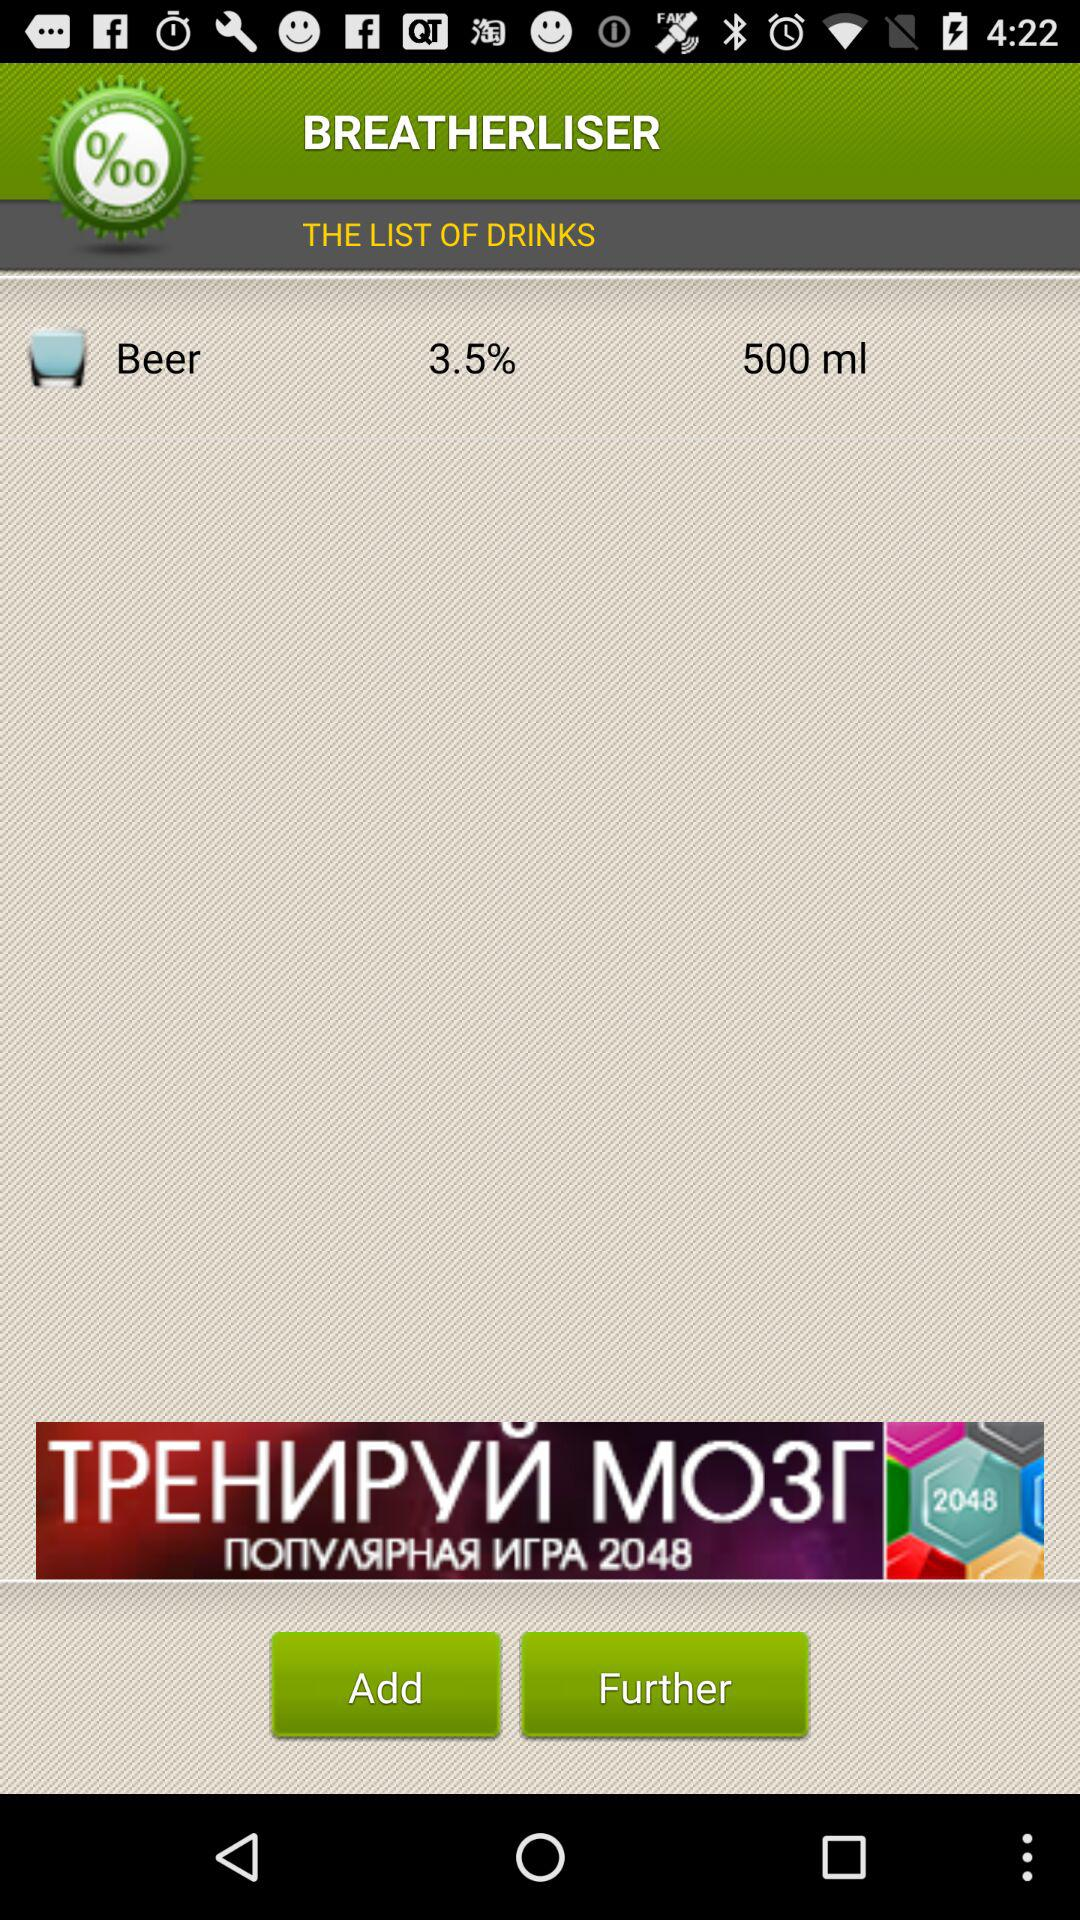How many glasses of beer has the user had?
When the provided information is insufficient, respond with <no answer>. <no answer> 